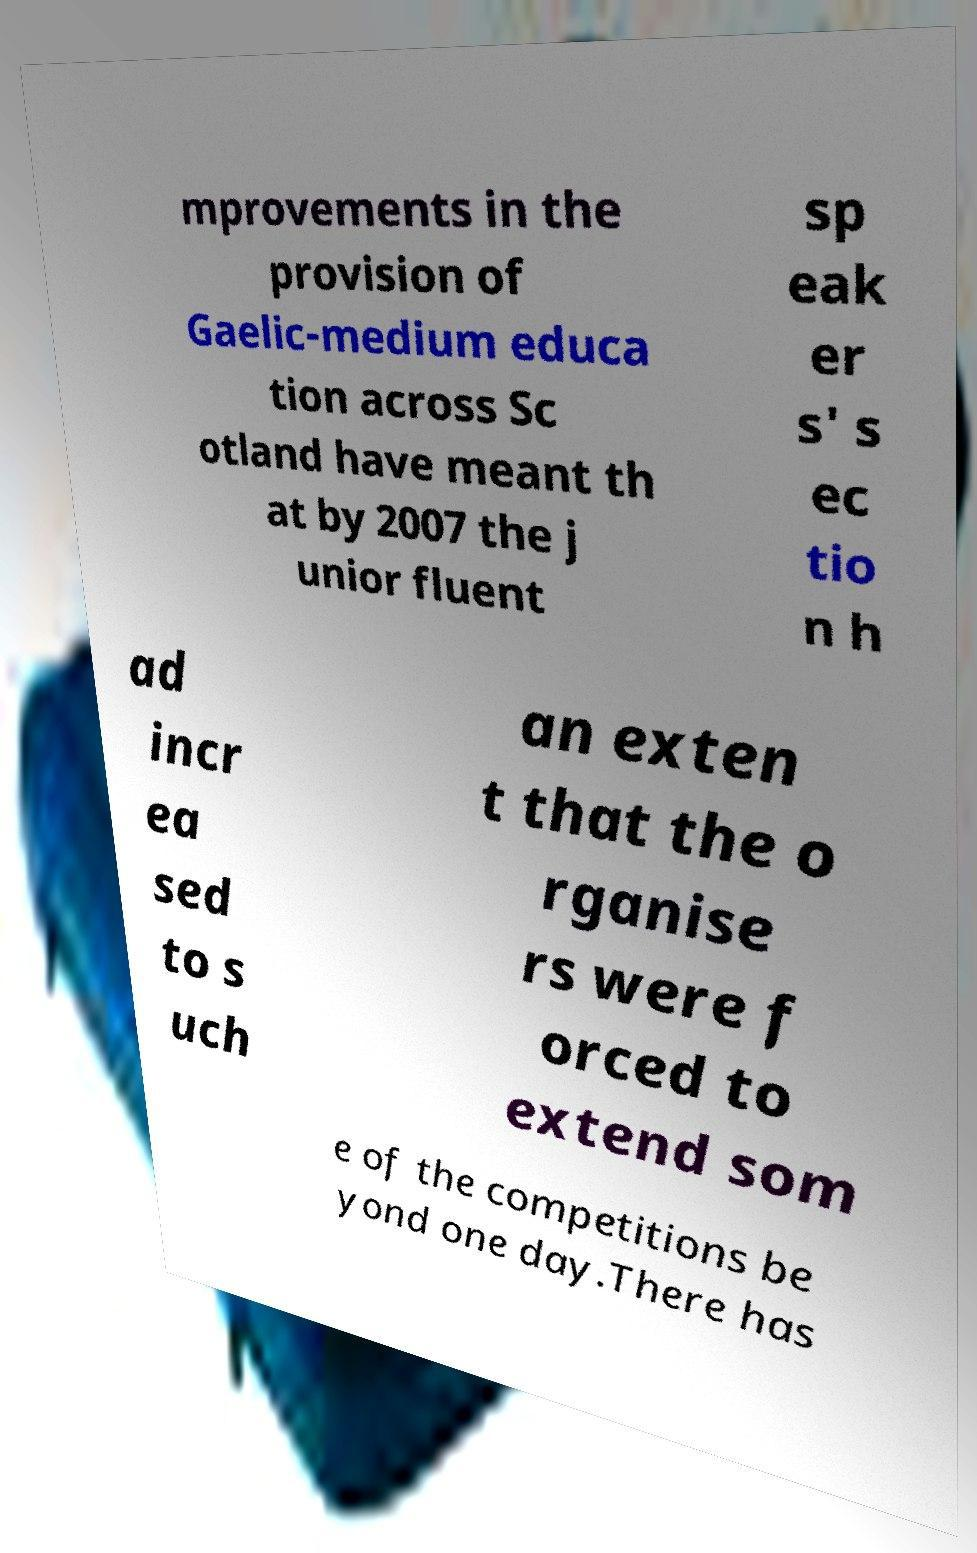Can you read and provide the text displayed in the image?This photo seems to have some interesting text. Can you extract and type it out for me? mprovements in the provision of Gaelic-medium educa tion across Sc otland have meant th at by 2007 the j unior fluent sp eak er s' s ec tio n h ad incr ea sed to s uch an exten t that the o rganise rs were f orced to extend som e of the competitions be yond one day.There has 